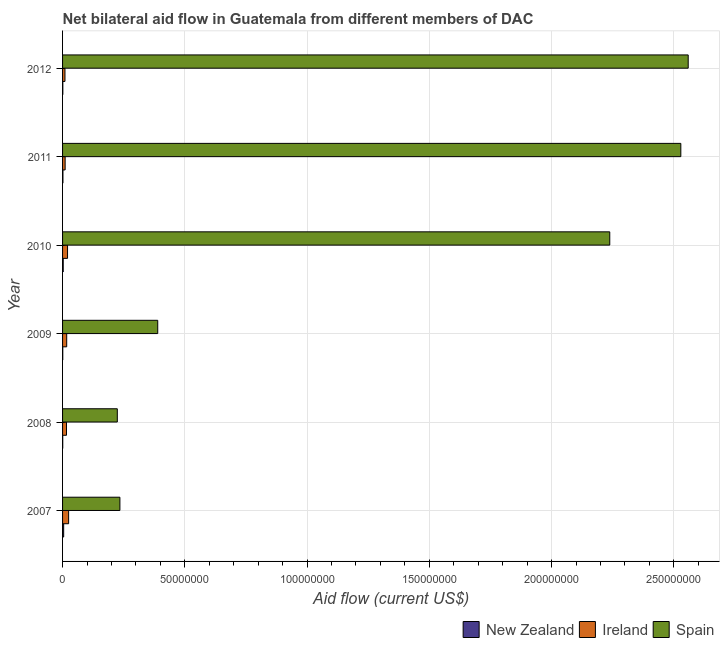How many different coloured bars are there?
Your answer should be very brief. 3. How many groups of bars are there?
Provide a short and direct response. 6. How many bars are there on the 6th tick from the top?
Give a very brief answer. 3. What is the amount of aid provided by ireland in 2007?
Offer a terse response. 2.48e+06. Across all years, what is the maximum amount of aid provided by spain?
Give a very brief answer. 2.56e+08. Across all years, what is the minimum amount of aid provided by new zealand?
Your answer should be compact. 7.00e+04. What is the total amount of aid provided by new zealand in the graph?
Give a very brief answer. 1.13e+06. What is the difference between the amount of aid provided by ireland in 2009 and that in 2012?
Offer a terse response. 7.10e+05. What is the difference between the amount of aid provided by new zealand in 2007 and the amount of aid provided by ireland in 2012?
Your response must be concise. -5.30e+05. What is the average amount of aid provided by new zealand per year?
Your answer should be compact. 1.88e+05. In the year 2011, what is the difference between the amount of aid provided by new zealand and amount of aid provided by spain?
Keep it short and to the point. -2.53e+08. What is the ratio of the amount of aid provided by new zealand in 2009 to that in 2010?
Offer a terse response. 0.3. Is the difference between the amount of aid provided by new zealand in 2009 and 2011 greater than the difference between the amount of aid provided by ireland in 2009 and 2011?
Your response must be concise. No. What is the difference between the highest and the second highest amount of aid provided by spain?
Make the answer very short. 3.02e+06. What is the difference between the highest and the lowest amount of aid provided by spain?
Give a very brief answer. 2.33e+08. Is the sum of the amount of aid provided by new zealand in 2007 and 2010 greater than the maximum amount of aid provided by spain across all years?
Ensure brevity in your answer.  No. What does the 3rd bar from the top in 2012 represents?
Offer a very short reply. New Zealand. What does the 2nd bar from the bottom in 2010 represents?
Offer a very short reply. Ireland. Is it the case that in every year, the sum of the amount of aid provided by new zealand and amount of aid provided by ireland is greater than the amount of aid provided by spain?
Keep it short and to the point. No. How many bars are there?
Make the answer very short. 18. How many years are there in the graph?
Give a very brief answer. 6. What is the difference between two consecutive major ticks on the X-axis?
Ensure brevity in your answer.  5.00e+07. Does the graph contain any zero values?
Keep it short and to the point. No. Where does the legend appear in the graph?
Offer a very short reply. Bottom right. What is the title of the graph?
Your answer should be compact. Net bilateral aid flow in Guatemala from different members of DAC. What is the label or title of the X-axis?
Keep it short and to the point. Aid flow (current US$). What is the Aid flow (current US$) in New Zealand in 2007?
Keep it short and to the point. 4.50e+05. What is the Aid flow (current US$) of Ireland in 2007?
Offer a very short reply. 2.48e+06. What is the Aid flow (current US$) in Spain in 2007?
Your response must be concise. 2.34e+07. What is the Aid flow (current US$) in New Zealand in 2008?
Your answer should be very brief. 7.00e+04. What is the Aid flow (current US$) of Ireland in 2008?
Provide a succinct answer. 1.61e+06. What is the Aid flow (current US$) in Spain in 2008?
Make the answer very short. 2.24e+07. What is the Aid flow (current US$) of New Zealand in 2009?
Give a very brief answer. 8.00e+04. What is the Aid flow (current US$) of Ireland in 2009?
Offer a terse response. 1.69e+06. What is the Aid flow (current US$) in Spain in 2009?
Provide a succinct answer. 3.89e+07. What is the Aid flow (current US$) in Ireland in 2010?
Your answer should be compact. 2.04e+06. What is the Aid flow (current US$) of Spain in 2010?
Your answer should be compact. 2.24e+08. What is the Aid flow (current US$) of New Zealand in 2011?
Keep it short and to the point. 1.50e+05. What is the Aid flow (current US$) in Ireland in 2011?
Give a very brief answer. 1.05e+06. What is the Aid flow (current US$) of Spain in 2011?
Give a very brief answer. 2.53e+08. What is the Aid flow (current US$) of Ireland in 2012?
Provide a succinct answer. 9.80e+05. What is the Aid flow (current US$) of Spain in 2012?
Your response must be concise. 2.56e+08. Across all years, what is the maximum Aid flow (current US$) in New Zealand?
Offer a terse response. 4.50e+05. Across all years, what is the maximum Aid flow (current US$) in Ireland?
Your answer should be compact. 2.48e+06. Across all years, what is the maximum Aid flow (current US$) in Spain?
Your response must be concise. 2.56e+08. Across all years, what is the minimum Aid flow (current US$) of New Zealand?
Your answer should be very brief. 7.00e+04. Across all years, what is the minimum Aid flow (current US$) in Ireland?
Provide a short and direct response. 9.80e+05. Across all years, what is the minimum Aid flow (current US$) of Spain?
Give a very brief answer. 2.24e+07. What is the total Aid flow (current US$) of New Zealand in the graph?
Offer a very short reply. 1.13e+06. What is the total Aid flow (current US$) of Ireland in the graph?
Offer a very short reply. 9.85e+06. What is the total Aid flow (current US$) of Spain in the graph?
Your answer should be compact. 8.17e+08. What is the difference between the Aid flow (current US$) in New Zealand in 2007 and that in 2008?
Your response must be concise. 3.80e+05. What is the difference between the Aid flow (current US$) of Ireland in 2007 and that in 2008?
Your answer should be very brief. 8.70e+05. What is the difference between the Aid flow (current US$) of Spain in 2007 and that in 2008?
Make the answer very short. 1.06e+06. What is the difference between the Aid flow (current US$) in New Zealand in 2007 and that in 2009?
Your response must be concise. 3.70e+05. What is the difference between the Aid flow (current US$) of Ireland in 2007 and that in 2009?
Provide a short and direct response. 7.90e+05. What is the difference between the Aid flow (current US$) in Spain in 2007 and that in 2009?
Your answer should be compact. -1.55e+07. What is the difference between the Aid flow (current US$) of Spain in 2007 and that in 2010?
Make the answer very short. -2.00e+08. What is the difference between the Aid flow (current US$) of Ireland in 2007 and that in 2011?
Your answer should be compact. 1.43e+06. What is the difference between the Aid flow (current US$) of Spain in 2007 and that in 2011?
Give a very brief answer. -2.29e+08. What is the difference between the Aid flow (current US$) in Ireland in 2007 and that in 2012?
Give a very brief answer. 1.50e+06. What is the difference between the Aid flow (current US$) in Spain in 2007 and that in 2012?
Keep it short and to the point. -2.32e+08. What is the difference between the Aid flow (current US$) of New Zealand in 2008 and that in 2009?
Your answer should be very brief. -10000. What is the difference between the Aid flow (current US$) of Spain in 2008 and that in 2009?
Offer a terse response. -1.65e+07. What is the difference between the Aid flow (current US$) of Ireland in 2008 and that in 2010?
Provide a short and direct response. -4.30e+05. What is the difference between the Aid flow (current US$) of Spain in 2008 and that in 2010?
Your answer should be very brief. -2.01e+08. What is the difference between the Aid flow (current US$) of Ireland in 2008 and that in 2011?
Keep it short and to the point. 5.60e+05. What is the difference between the Aid flow (current US$) of Spain in 2008 and that in 2011?
Offer a very short reply. -2.30e+08. What is the difference between the Aid flow (current US$) of Ireland in 2008 and that in 2012?
Your answer should be compact. 6.30e+05. What is the difference between the Aid flow (current US$) in Spain in 2008 and that in 2012?
Provide a short and direct response. -2.33e+08. What is the difference between the Aid flow (current US$) of Ireland in 2009 and that in 2010?
Your response must be concise. -3.50e+05. What is the difference between the Aid flow (current US$) of Spain in 2009 and that in 2010?
Offer a very short reply. -1.85e+08. What is the difference between the Aid flow (current US$) of New Zealand in 2009 and that in 2011?
Ensure brevity in your answer.  -7.00e+04. What is the difference between the Aid flow (current US$) in Ireland in 2009 and that in 2011?
Your answer should be compact. 6.40e+05. What is the difference between the Aid flow (current US$) in Spain in 2009 and that in 2011?
Your answer should be very brief. -2.14e+08. What is the difference between the Aid flow (current US$) of New Zealand in 2009 and that in 2012?
Offer a terse response. -3.00e+04. What is the difference between the Aid flow (current US$) in Ireland in 2009 and that in 2012?
Offer a very short reply. 7.10e+05. What is the difference between the Aid flow (current US$) in Spain in 2009 and that in 2012?
Give a very brief answer. -2.17e+08. What is the difference between the Aid flow (current US$) in Ireland in 2010 and that in 2011?
Offer a very short reply. 9.90e+05. What is the difference between the Aid flow (current US$) of Spain in 2010 and that in 2011?
Keep it short and to the point. -2.91e+07. What is the difference between the Aid flow (current US$) in Ireland in 2010 and that in 2012?
Your answer should be very brief. 1.06e+06. What is the difference between the Aid flow (current US$) in Spain in 2010 and that in 2012?
Keep it short and to the point. -3.21e+07. What is the difference between the Aid flow (current US$) in New Zealand in 2011 and that in 2012?
Ensure brevity in your answer.  4.00e+04. What is the difference between the Aid flow (current US$) in Ireland in 2011 and that in 2012?
Your response must be concise. 7.00e+04. What is the difference between the Aid flow (current US$) of Spain in 2011 and that in 2012?
Your response must be concise. -3.02e+06. What is the difference between the Aid flow (current US$) in New Zealand in 2007 and the Aid flow (current US$) in Ireland in 2008?
Give a very brief answer. -1.16e+06. What is the difference between the Aid flow (current US$) in New Zealand in 2007 and the Aid flow (current US$) in Spain in 2008?
Offer a very short reply. -2.19e+07. What is the difference between the Aid flow (current US$) of Ireland in 2007 and the Aid flow (current US$) of Spain in 2008?
Your answer should be very brief. -1.99e+07. What is the difference between the Aid flow (current US$) in New Zealand in 2007 and the Aid flow (current US$) in Ireland in 2009?
Make the answer very short. -1.24e+06. What is the difference between the Aid flow (current US$) of New Zealand in 2007 and the Aid flow (current US$) of Spain in 2009?
Your response must be concise. -3.85e+07. What is the difference between the Aid flow (current US$) of Ireland in 2007 and the Aid flow (current US$) of Spain in 2009?
Ensure brevity in your answer.  -3.64e+07. What is the difference between the Aid flow (current US$) in New Zealand in 2007 and the Aid flow (current US$) in Ireland in 2010?
Ensure brevity in your answer.  -1.59e+06. What is the difference between the Aid flow (current US$) of New Zealand in 2007 and the Aid flow (current US$) of Spain in 2010?
Make the answer very short. -2.23e+08. What is the difference between the Aid flow (current US$) in Ireland in 2007 and the Aid flow (current US$) in Spain in 2010?
Provide a succinct answer. -2.21e+08. What is the difference between the Aid flow (current US$) in New Zealand in 2007 and the Aid flow (current US$) in Ireland in 2011?
Provide a short and direct response. -6.00e+05. What is the difference between the Aid flow (current US$) in New Zealand in 2007 and the Aid flow (current US$) in Spain in 2011?
Keep it short and to the point. -2.52e+08. What is the difference between the Aid flow (current US$) in Ireland in 2007 and the Aid flow (current US$) in Spain in 2011?
Make the answer very short. -2.50e+08. What is the difference between the Aid flow (current US$) of New Zealand in 2007 and the Aid flow (current US$) of Ireland in 2012?
Offer a very short reply. -5.30e+05. What is the difference between the Aid flow (current US$) in New Zealand in 2007 and the Aid flow (current US$) in Spain in 2012?
Keep it short and to the point. -2.55e+08. What is the difference between the Aid flow (current US$) of Ireland in 2007 and the Aid flow (current US$) of Spain in 2012?
Give a very brief answer. -2.53e+08. What is the difference between the Aid flow (current US$) of New Zealand in 2008 and the Aid flow (current US$) of Ireland in 2009?
Your response must be concise. -1.62e+06. What is the difference between the Aid flow (current US$) in New Zealand in 2008 and the Aid flow (current US$) in Spain in 2009?
Your response must be concise. -3.88e+07. What is the difference between the Aid flow (current US$) of Ireland in 2008 and the Aid flow (current US$) of Spain in 2009?
Your answer should be very brief. -3.73e+07. What is the difference between the Aid flow (current US$) of New Zealand in 2008 and the Aid flow (current US$) of Ireland in 2010?
Your answer should be compact. -1.97e+06. What is the difference between the Aid flow (current US$) of New Zealand in 2008 and the Aid flow (current US$) of Spain in 2010?
Offer a very short reply. -2.24e+08. What is the difference between the Aid flow (current US$) of Ireland in 2008 and the Aid flow (current US$) of Spain in 2010?
Give a very brief answer. -2.22e+08. What is the difference between the Aid flow (current US$) of New Zealand in 2008 and the Aid flow (current US$) of Ireland in 2011?
Your answer should be very brief. -9.80e+05. What is the difference between the Aid flow (current US$) of New Zealand in 2008 and the Aid flow (current US$) of Spain in 2011?
Give a very brief answer. -2.53e+08. What is the difference between the Aid flow (current US$) of Ireland in 2008 and the Aid flow (current US$) of Spain in 2011?
Offer a terse response. -2.51e+08. What is the difference between the Aid flow (current US$) in New Zealand in 2008 and the Aid flow (current US$) in Ireland in 2012?
Provide a short and direct response. -9.10e+05. What is the difference between the Aid flow (current US$) of New Zealand in 2008 and the Aid flow (current US$) of Spain in 2012?
Your response must be concise. -2.56e+08. What is the difference between the Aid flow (current US$) of Ireland in 2008 and the Aid flow (current US$) of Spain in 2012?
Provide a succinct answer. -2.54e+08. What is the difference between the Aid flow (current US$) in New Zealand in 2009 and the Aid flow (current US$) in Ireland in 2010?
Your answer should be very brief. -1.96e+06. What is the difference between the Aid flow (current US$) in New Zealand in 2009 and the Aid flow (current US$) in Spain in 2010?
Your answer should be very brief. -2.24e+08. What is the difference between the Aid flow (current US$) of Ireland in 2009 and the Aid flow (current US$) of Spain in 2010?
Offer a very short reply. -2.22e+08. What is the difference between the Aid flow (current US$) of New Zealand in 2009 and the Aid flow (current US$) of Ireland in 2011?
Ensure brevity in your answer.  -9.70e+05. What is the difference between the Aid flow (current US$) in New Zealand in 2009 and the Aid flow (current US$) in Spain in 2011?
Offer a terse response. -2.53e+08. What is the difference between the Aid flow (current US$) of Ireland in 2009 and the Aid flow (current US$) of Spain in 2011?
Make the answer very short. -2.51e+08. What is the difference between the Aid flow (current US$) of New Zealand in 2009 and the Aid flow (current US$) of Ireland in 2012?
Ensure brevity in your answer.  -9.00e+05. What is the difference between the Aid flow (current US$) of New Zealand in 2009 and the Aid flow (current US$) of Spain in 2012?
Offer a terse response. -2.56e+08. What is the difference between the Aid flow (current US$) of Ireland in 2009 and the Aid flow (current US$) of Spain in 2012?
Ensure brevity in your answer.  -2.54e+08. What is the difference between the Aid flow (current US$) of New Zealand in 2010 and the Aid flow (current US$) of Ireland in 2011?
Offer a very short reply. -7.80e+05. What is the difference between the Aid flow (current US$) in New Zealand in 2010 and the Aid flow (current US$) in Spain in 2011?
Offer a terse response. -2.53e+08. What is the difference between the Aid flow (current US$) in Ireland in 2010 and the Aid flow (current US$) in Spain in 2011?
Give a very brief answer. -2.51e+08. What is the difference between the Aid flow (current US$) in New Zealand in 2010 and the Aid flow (current US$) in Ireland in 2012?
Keep it short and to the point. -7.10e+05. What is the difference between the Aid flow (current US$) of New Zealand in 2010 and the Aid flow (current US$) of Spain in 2012?
Offer a terse response. -2.56e+08. What is the difference between the Aid flow (current US$) in Ireland in 2010 and the Aid flow (current US$) in Spain in 2012?
Your response must be concise. -2.54e+08. What is the difference between the Aid flow (current US$) of New Zealand in 2011 and the Aid flow (current US$) of Ireland in 2012?
Provide a short and direct response. -8.30e+05. What is the difference between the Aid flow (current US$) of New Zealand in 2011 and the Aid flow (current US$) of Spain in 2012?
Your answer should be compact. -2.56e+08. What is the difference between the Aid flow (current US$) in Ireland in 2011 and the Aid flow (current US$) in Spain in 2012?
Keep it short and to the point. -2.55e+08. What is the average Aid flow (current US$) of New Zealand per year?
Give a very brief answer. 1.88e+05. What is the average Aid flow (current US$) in Ireland per year?
Give a very brief answer. 1.64e+06. What is the average Aid flow (current US$) of Spain per year?
Ensure brevity in your answer.  1.36e+08. In the year 2007, what is the difference between the Aid flow (current US$) in New Zealand and Aid flow (current US$) in Ireland?
Your answer should be compact. -2.03e+06. In the year 2007, what is the difference between the Aid flow (current US$) in New Zealand and Aid flow (current US$) in Spain?
Provide a short and direct response. -2.30e+07. In the year 2007, what is the difference between the Aid flow (current US$) in Ireland and Aid flow (current US$) in Spain?
Provide a short and direct response. -2.10e+07. In the year 2008, what is the difference between the Aid flow (current US$) of New Zealand and Aid flow (current US$) of Ireland?
Your answer should be very brief. -1.54e+06. In the year 2008, what is the difference between the Aid flow (current US$) of New Zealand and Aid flow (current US$) of Spain?
Offer a very short reply. -2.23e+07. In the year 2008, what is the difference between the Aid flow (current US$) of Ireland and Aid flow (current US$) of Spain?
Ensure brevity in your answer.  -2.08e+07. In the year 2009, what is the difference between the Aid flow (current US$) of New Zealand and Aid flow (current US$) of Ireland?
Keep it short and to the point. -1.61e+06. In the year 2009, what is the difference between the Aid flow (current US$) of New Zealand and Aid flow (current US$) of Spain?
Your answer should be compact. -3.88e+07. In the year 2009, what is the difference between the Aid flow (current US$) in Ireland and Aid flow (current US$) in Spain?
Provide a succinct answer. -3.72e+07. In the year 2010, what is the difference between the Aid flow (current US$) in New Zealand and Aid flow (current US$) in Ireland?
Offer a terse response. -1.77e+06. In the year 2010, what is the difference between the Aid flow (current US$) of New Zealand and Aid flow (current US$) of Spain?
Keep it short and to the point. -2.24e+08. In the year 2010, what is the difference between the Aid flow (current US$) in Ireland and Aid flow (current US$) in Spain?
Make the answer very short. -2.22e+08. In the year 2011, what is the difference between the Aid flow (current US$) in New Zealand and Aid flow (current US$) in Ireland?
Your answer should be compact. -9.00e+05. In the year 2011, what is the difference between the Aid flow (current US$) in New Zealand and Aid flow (current US$) in Spain?
Keep it short and to the point. -2.53e+08. In the year 2011, what is the difference between the Aid flow (current US$) of Ireland and Aid flow (current US$) of Spain?
Your response must be concise. -2.52e+08. In the year 2012, what is the difference between the Aid flow (current US$) of New Zealand and Aid flow (current US$) of Ireland?
Make the answer very short. -8.70e+05. In the year 2012, what is the difference between the Aid flow (current US$) of New Zealand and Aid flow (current US$) of Spain?
Ensure brevity in your answer.  -2.56e+08. In the year 2012, what is the difference between the Aid flow (current US$) of Ireland and Aid flow (current US$) of Spain?
Provide a succinct answer. -2.55e+08. What is the ratio of the Aid flow (current US$) of New Zealand in 2007 to that in 2008?
Your response must be concise. 6.43. What is the ratio of the Aid flow (current US$) of Ireland in 2007 to that in 2008?
Your answer should be very brief. 1.54. What is the ratio of the Aid flow (current US$) in Spain in 2007 to that in 2008?
Provide a succinct answer. 1.05. What is the ratio of the Aid flow (current US$) of New Zealand in 2007 to that in 2009?
Offer a terse response. 5.62. What is the ratio of the Aid flow (current US$) in Ireland in 2007 to that in 2009?
Your answer should be very brief. 1.47. What is the ratio of the Aid flow (current US$) of Spain in 2007 to that in 2009?
Your response must be concise. 0.6. What is the ratio of the Aid flow (current US$) in New Zealand in 2007 to that in 2010?
Keep it short and to the point. 1.67. What is the ratio of the Aid flow (current US$) in Ireland in 2007 to that in 2010?
Provide a succinct answer. 1.22. What is the ratio of the Aid flow (current US$) in Spain in 2007 to that in 2010?
Make the answer very short. 0.1. What is the ratio of the Aid flow (current US$) of New Zealand in 2007 to that in 2011?
Your answer should be very brief. 3. What is the ratio of the Aid flow (current US$) of Ireland in 2007 to that in 2011?
Ensure brevity in your answer.  2.36. What is the ratio of the Aid flow (current US$) in Spain in 2007 to that in 2011?
Keep it short and to the point. 0.09. What is the ratio of the Aid flow (current US$) of New Zealand in 2007 to that in 2012?
Provide a short and direct response. 4.09. What is the ratio of the Aid flow (current US$) of Ireland in 2007 to that in 2012?
Provide a succinct answer. 2.53. What is the ratio of the Aid flow (current US$) of Spain in 2007 to that in 2012?
Provide a succinct answer. 0.09. What is the ratio of the Aid flow (current US$) in New Zealand in 2008 to that in 2009?
Your response must be concise. 0.88. What is the ratio of the Aid flow (current US$) of Ireland in 2008 to that in 2009?
Your answer should be very brief. 0.95. What is the ratio of the Aid flow (current US$) in Spain in 2008 to that in 2009?
Offer a terse response. 0.58. What is the ratio of the Aid flow (current US$) in New Zealand in 2008 to that in 2010?
Your answer should be compact. 0.26. What is the ratio of the Aid flow (current US$) of Ireland in 2008 to that in 2010?
Your answer should be very brief. 0.79. What is the ratio of the Aid flow (current US$) of New Zealand in 2008 to that in 2011?
Your response must be concise. 0.47. What is the ratio of the Aid flow (current US$) in Ireland in 2008 to that in 2011?
Your answer should be very brief. 1.53. What is the ratio of the Aid flow (current US$) in Spain in 2008 to that in 2011?
Your response must be concise. 0.09. What is the ratio of the Aid flow (current US$) of New Zealand in 2008 to that in 2012?
Give a very brief answer. 0.64. What is the ratio of the Aid flow (current US$) of Ireland in 2008 to that in 2012?
Your answer should be very brief. 1.64. What is the ratio of the Aid flow (current US$) of Spain in 2008 to that in 2012?
Give a very brief answer. 0.09. What is the ratio of the Aid flow (current US$) of New Zealand in 2009 to that in 2010?
Make the answer very short. 0.3. What is the ratio of the Aid flow (current US$) in Ireland in 2009 to that in 2010?
Your answer should be very brief. 0.83. What is the ratio of the Aid flow (current US$) of Spain in 2009 to that in 2010?
Provide a short and direct response. 0.17. What is the ratio of the Aid flow (current US$) in New Zealand in 2009 to that in 2011?
Offer a terse response. 0.53. What is the ratio of the Aid flow (current US$) of Ireland in 2009 to that in 2011?
Give a very brief answer. 1.61. What is the ratio of the Aid flow (current US$) in Spain in 2009 to that in 2011?
Give a very brief answer. 0.15. What is the ratio of the Aid flow (current US$) in New Zealand in 2009 to that in 2012?
Your answer should be very brief. 0.73. What is the ratio of the Aid flow (current US$) of Ireland in 2009 to that in 2012?
Offer a terse response. 1.72. What is the ratio of the Aid flow (current US$) of Spain in 2009 to that in 2012?
Keep it short and to the point. 0.15. What is the ratio of the Aid flow (current US$) of New Zealand in 2010 to that in 2011?
Keep it short and to the point. 1.8. What is the ratio of the Aid flow (current US$) in Ireland in 2010 to that in 2011?
Your answer should be very brief. 1.94. What is the ratio of the Aid flow (current US$) in Spain in 2010 to that in 2011?
Offer a very short reply. 0.89. What is the ratio of the Aid flow (current US$) of New Zealand in 2010 to that in 2012?
Provide a succinct answer. 2.45. What is the ratio of the Aid flow (current US$) in Ireland in 2010 to that in 2012?
Ensure brevity in your answer.  2.08. What is the ratio of the Aid flow (current US$) of Spain in 2010 to that in 2012?
Make the answer very short. 0.87. What is the ratio of the Aid flow (current US$) in New Zealand in 2011 to that in 2012?
Keep it short and to the point. 1.36. What is the ratio of the Aid flow (current US$) of Ireland in 2011 to that in 2012?
Ensure brevity in your answer.  1.07. What is the difference between the highest and the second highest Aid flow (current US$) of Ireland?
Your response must be concise. 4.40e+05. What is the difference between the highest and the second highest Aid flow (current US$) in Spain?
Provide a succinct answer. 3.02e+06. What is the difference between the highest and the lowest Aid flow (current US$) in Ireland?
Give a very brief answer. 1.50e+06. What is the difference between the highest and the lowest Aid flow (current US$) in Spain?
Provide a short and direct response. 2.33e+08. 